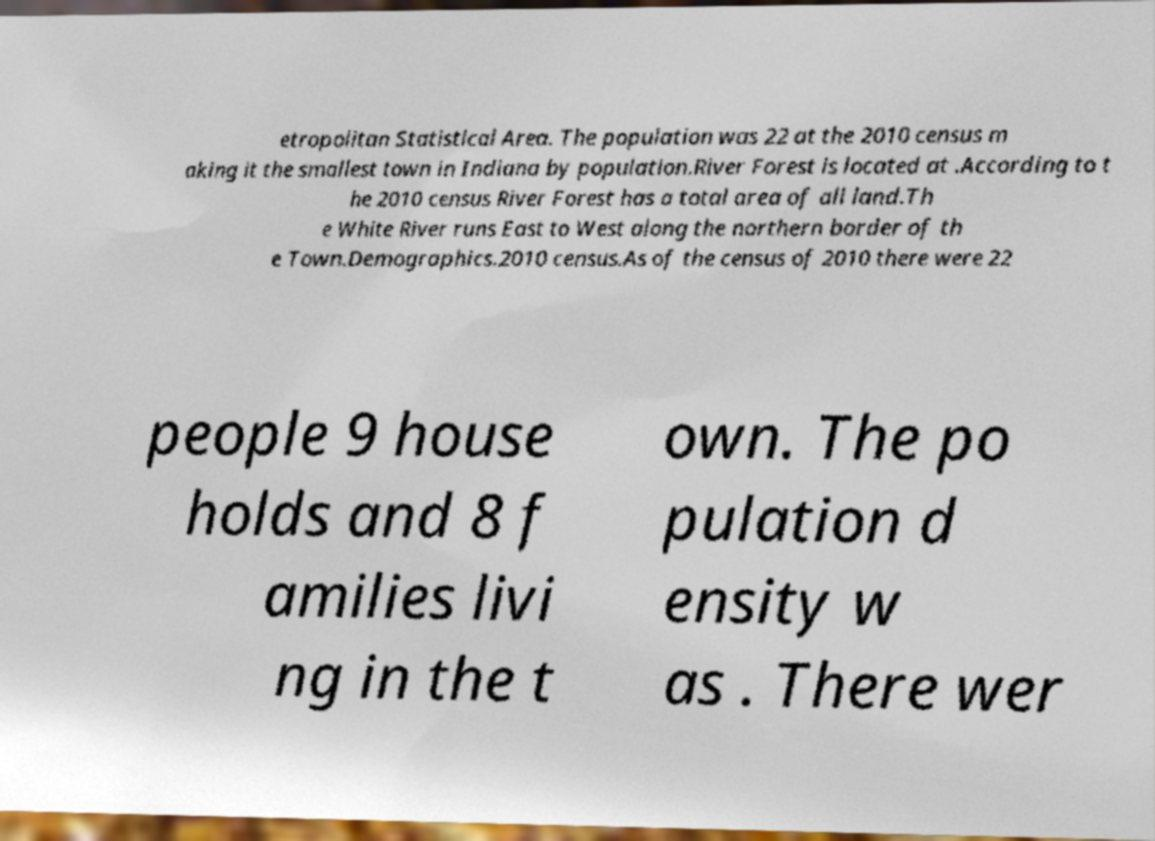There's text embedded in this image that I need extracted. Can you transcribe it verbatim? etropolitan Statistical Area. The population was 22 at the 2010 census m aking it the smallest town in Indiana by population.River Forest is located at .According to t he 2010 census River Forest has a total area of all land.Th e White River runs East to West along the northern border of th e Town.Demographics.2010 census.As of the census of 2010 there were 22 people 9 house holds and 8 f amilies livi ng in the t own. The po pulation d ensity w as . There wer 